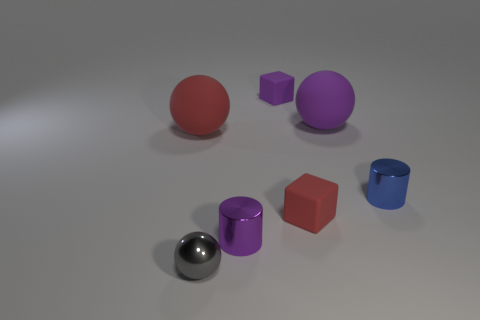What is the shape of the blue object that is the same size as the purple shiny cylinder?
Keep it short and to the point. Cylinder. Are there any other large red rubber objects of the same shape as the big red rubber thing?
Your answer should be compact. No. Is the small cylinder left of the small blue metal thing made of the same material as the gray object left of the big purple matte sphere?
Offer a terse response. Yes. How many big purple things have the same material as the blue thing?
Provide a short and direct response. 0. What color is the tiny ball?
Your answer should be compact. Gray. There is a small rubber object to the left of the tiny red rubber cube; is its shape the same as the red matte object that is on the right side of the tiny gray metallic thing?
Provide a succinct answer. Yes. There is a ball right of the gray metal object; what is its color?
Make the answer very short. Purple. Is the number of blue objects that are in front of the red rubber block less than the number of tiny red blocks left of the large red matte thing?
Make the answer very short. No. How many other things are there of the same material as the small red thing?
Your answer should be compact. 3. Is the material of the blue thing the same as the tiny gray ball?
Your answer should be very brief. Yes. 